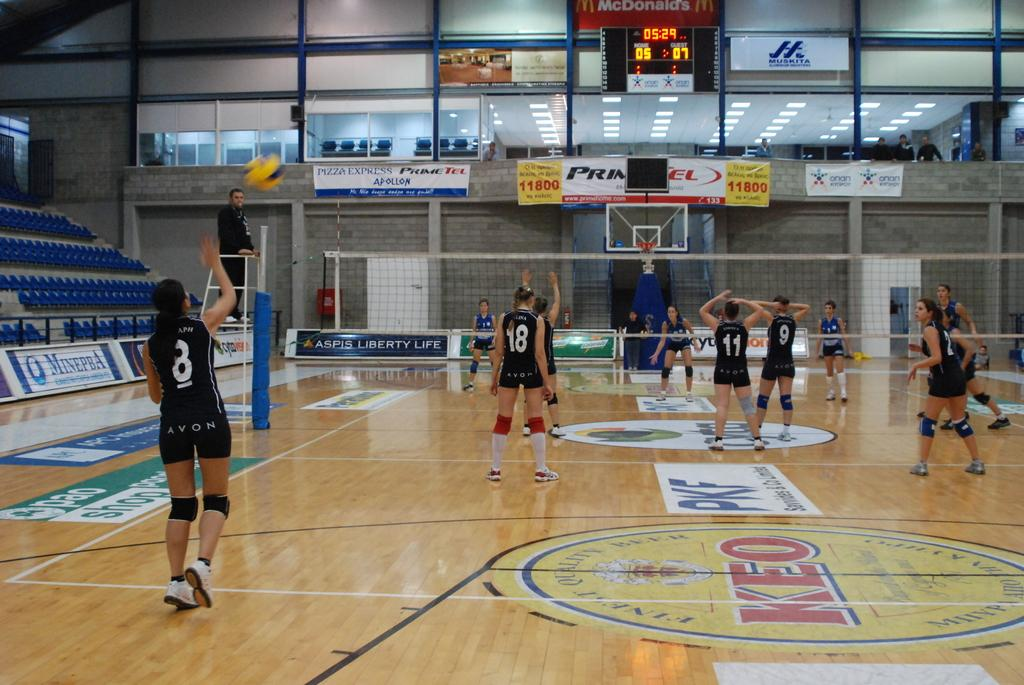<image>
Create a compact narrative representing the image presented. Volleyball players on the court with number 8 in the back. 